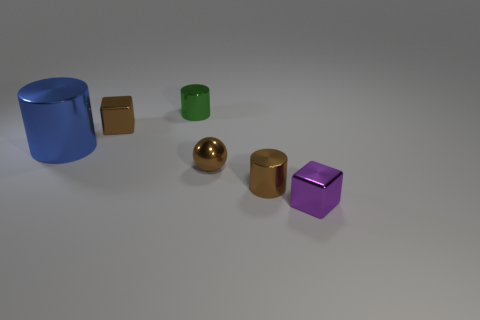There is a small cube that is the same color as the tiny ball; what material is it?
Make the answer very short. Metal. What number of metallic cubes are the same color as the metal sphere?
Provide a succinct answer. 1. Does the metal cylinder in front of the large metallic cylinder have the same color as the tiny shiny object left of the tiny green metal cylinder?
Provide a succinct answer. Yes. Are there any tiny brown shiny things in front of the green metal thing?
Provide a short and direct response. Yes. What is the brown cube made of?
Your answer should be compact. Metal. What is the shape of the brown thing that is behind the brown metallic ball?
Offer a very short reply. Cube. There is a shiny cylinder that is the same color as the small sphere; what is its size?
Your answer should be very brief. Small. Are there any brown matte blocks that have the same size as the purple metal thing?
Your answer should be very brief. No. Are there the same number of small brown shiny cylinders behind the brown cube and metal things to the right of the brown cylinder?
Offer a terse response. No. The brown metal thing that is both right of the green metal object and behind the brown metallic cylinder has what shape?
Provide a succinct answer. Sphere. 